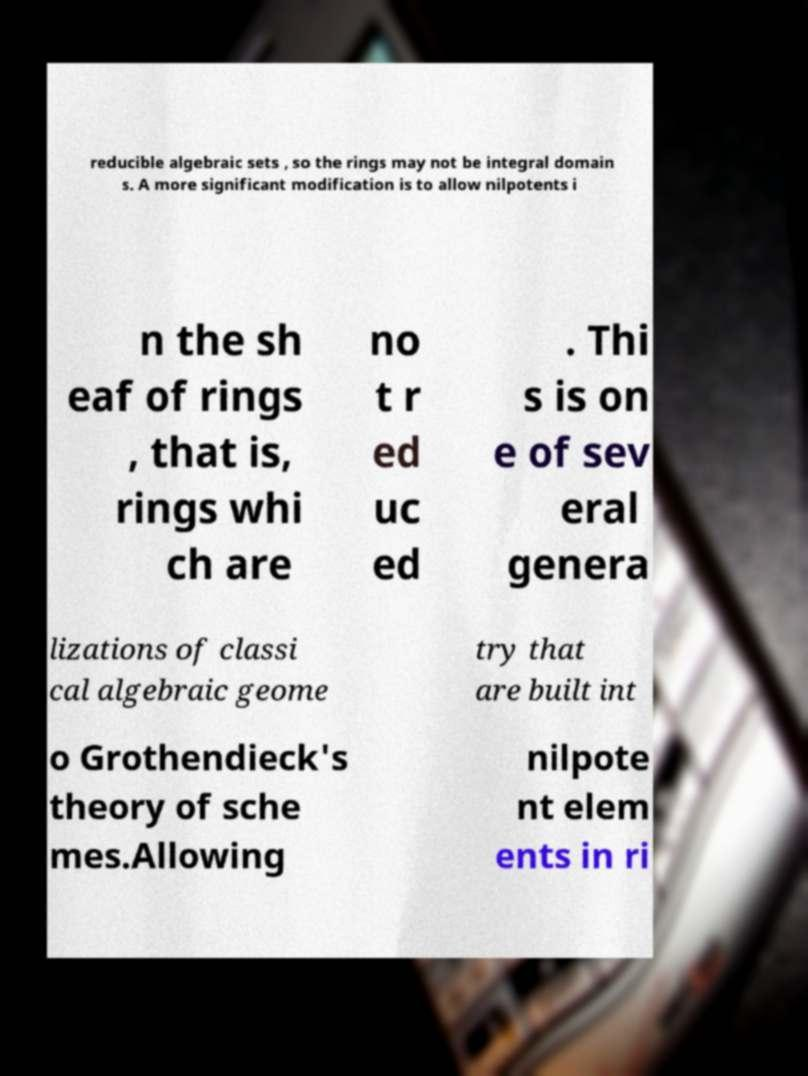Could you assist in decoding the text presented in this image and type it out clearly? reducible algebraic sets , so the rings may not be integral domain s. A more significant modification is to allow nilpotents i n the sh eaf of rings , that is, rings whi ch are no t r ed uc ed . Thi s is on e of sev eral genera lizations of classi cal algebraic geome try that are built int o Grothendieck's theory of sche mes.Allowing nilpote nt elem ents in ri 